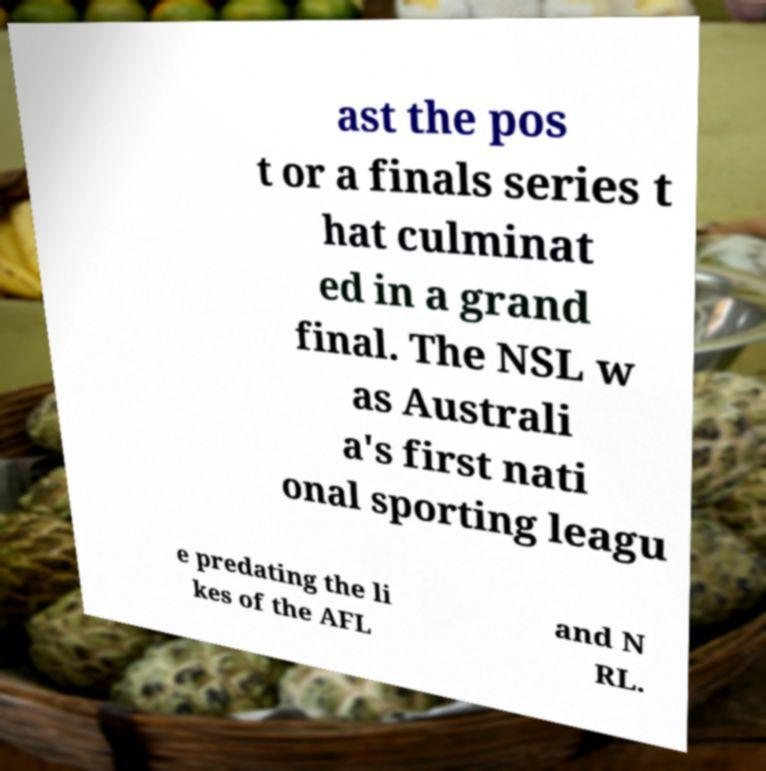What messages or text are displayed in this image? I need them in a readable, typed format. ast the pos t or a finals series t hat culminat ed in a grand final. The NSL w as Australi a's first nati onal sporting leagu e predating the li kes of the AFL and N RL. 